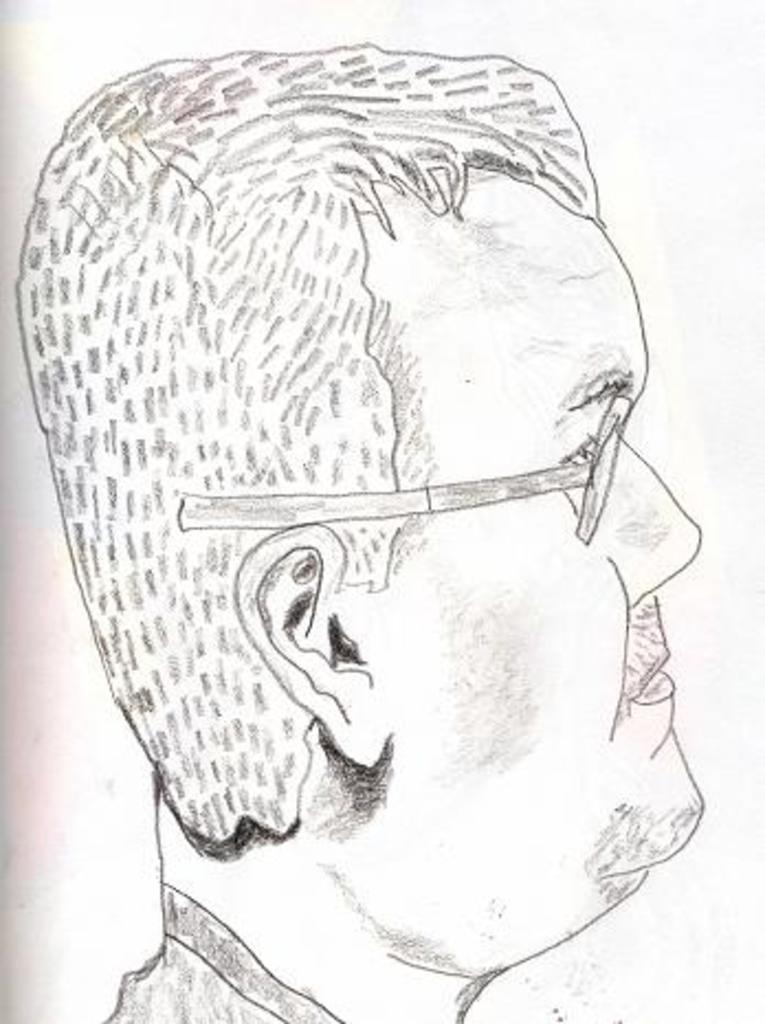What is depicted in the image? There is a sketch of a person in the image. Where is the father floating down the river in the image? There is no father or river present in the image; it only contains a sketch of a person. 